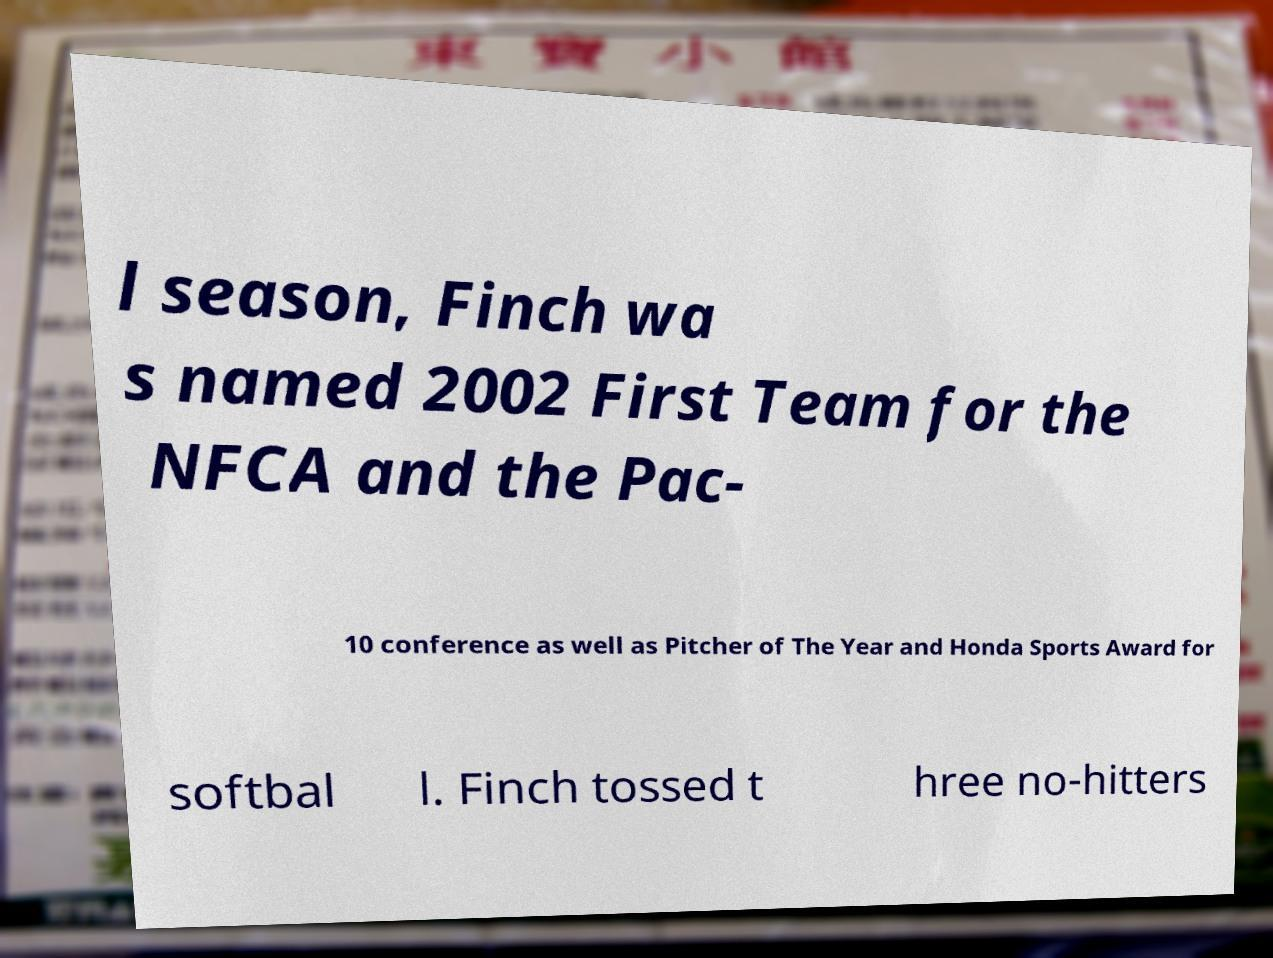Please read and relay the text visible in this image. What does it say? l season, Finch wa s named 2002 First Team for the NFCA and the Pac- 10 conference as well as Pitcher of The Year and Honda Sports Award for softbal l. Finch tossed t hree no-hitters 